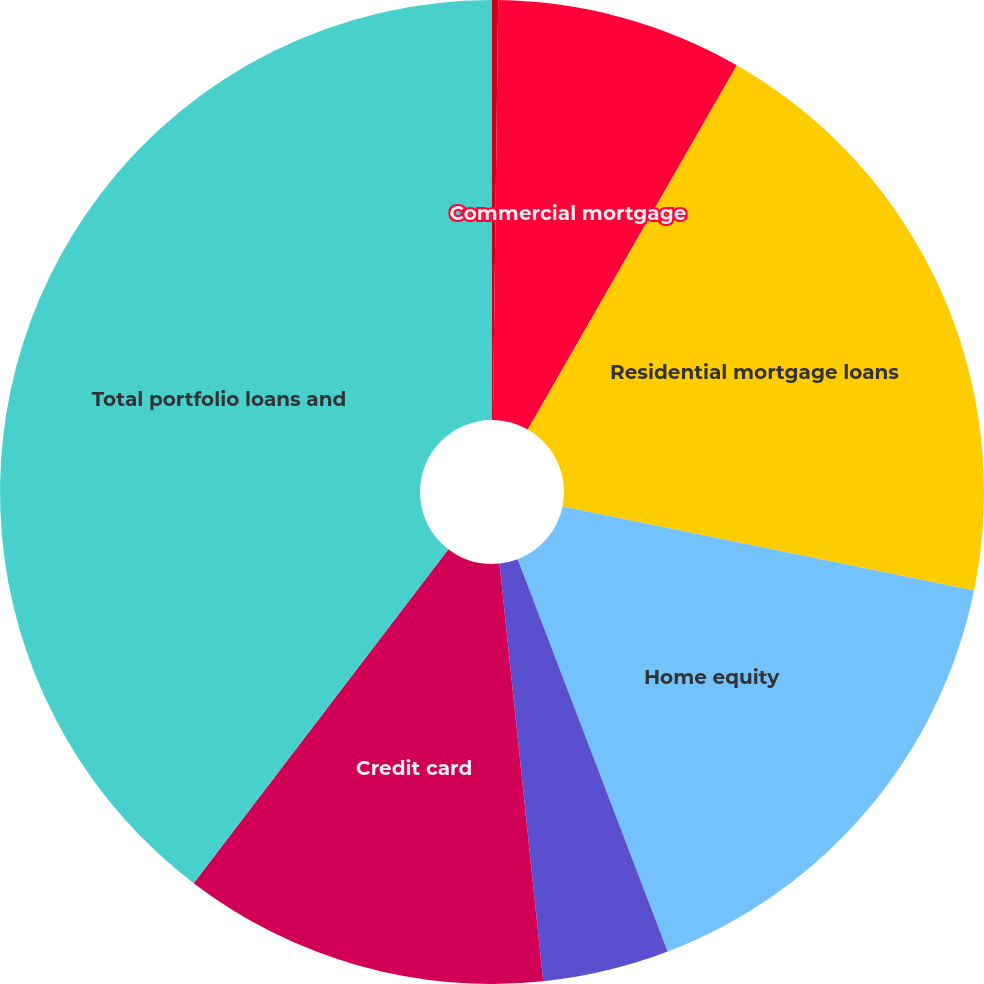Convert chart to OTSL. <chart><loc_0><loc_0><loc_500><loc_500><pie_chart><fcel>Commercial and industrial<fcel>Commercial mortgage<fcel>Residential mortgage loans<fcel>Home equity<fcel>Automobile loans<fcel>Credit card<fcel>Total portfolio loans and<nl><fcel>0.2%<fcel>8.09%<fcel>19.92%<fcel>15.98%<fcel>4.15%<fcel>12.03%<fcel>39.63%<nl></chart> 